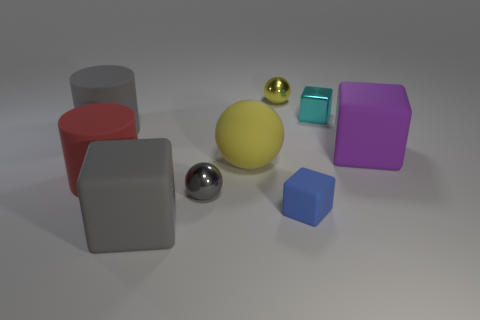What number of objects are either purple shiny cylinders or tiny metallic things that are to the left of the tiny yellow object?
Keep it short and to the point. 1. How many other things are there of the same color as the large sphere?
Keep it short and to the point. 1. There is a purple matte block; is it the same size as the metal object that is in front of the large purple rubber thing?
Your response must be concise. No. There is a yellow thing that is in front of the cyan metallic block; is its size the same as the gray cylinder?
Offer a terse response. Yes. What number of other things are there of the same material as the cyan thing
Give a very brief answer. 2. Are there the same number of cubes in front of the purple thing and metal objects that are on the right side of the small shiny block?
Provide a succinct answer. No. There is a metal ball in front of the large rubber cylinder that is in front of the large cube on the right side of the cyan metal block; what color is it?
Offer a terse response. Gray. What shape is the big thing behind the large purple matte thing?
Give a very brief answer. Cylinder. What shape is the small yellow object that is made of the same material as the gray ball?
Provide a short and direct response. Sphere. Is there anything else that has the same shape as the large purple matte thing?
Your answer should be compact. Yes. 